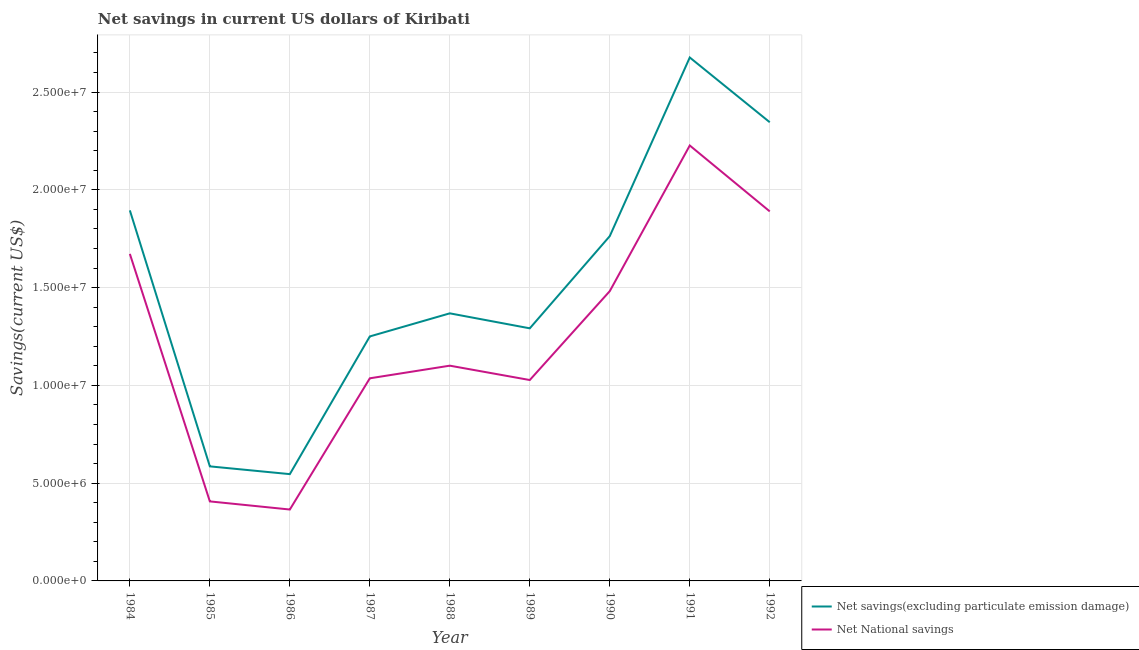How many different coloured lines are there?
Provide a short and direct response. 2. Does the line corresponding to net national savings intersect with the line corresponding to net savings(excluding particulate emission damage)?
Make the answer very short. No. What is the net national savings in 1992?
Offer a very short reply. 1.89e+07. Across all years, what is the maximum net savings(excluding particulate emission damage)?
Ensure brevity in your answer.  2.68e+07. Across all years, what is the minimum net national savings?
Give a very brief answer. 3.65e+06. In which year was the net savings(excluding particulate emission damage) maximum?
Make the answer very short. 1991. In which year was the net savings(excluding particulate emission damage) minimum?
Offer a terse response. 1986. What is the total net national savings in the graph?
Your answer should be compact. 1.12e+08. What is the difference between the net savings(excluding particulate emission damage) in 1986 and that in 1988?
Keep it short and to the point. -8.22e+06. What is the difference between the net savings(excluding particulate emission damage) in 1991 and the net national savings in 1992?
Keep it short and to the point. 7.87e+06. What is the average net national savings per year?
Provide a succinct answer. 1.25e+07. In the year 1987, what is the difference between the net national savings and net savings(excluding particulate emission damage)?
Provide a short and direct response. -2.14e+06. In how many years, is the net national savings greater than 10000000 US$?
Make the answer very short. 7. What is the ratio of the net national savings in 1985 to that in 1986?
Keep it short and to the point. 1.11. Is the net savings(excluding particulate emission damage) in 1987 less than that in 1988?
Keep it short and to the point. Yes. What is the difference between the highest and the second highest net national savings?
Your response must be concise. 3.37e+06. What is the difference between the highest and the lowest net national savings?
Your answer should be compact. 1.86e+07. Is the net national savings strictly less than the net savings(excluding particulate emission damage) over the years?
Make the answer very short. Yes. How many lines are there?
Offer a terse response. 2. What is the difference between two consecutive major ticks on the Y-axis?
Provide a short and direct response. 5.00e+06. Where does the legend appear in the graph?
Give a very brief answer. Bottom right. How are the legend labels stacked?
Provide a short and direct response. Vertical. What is the title of the graph?
Make the answer very short. Net savings in current US dollars of Kiribati. What is the label or title of the Y-axis?
Offer a terse response. Savings(current US$). What is the Savings(current US$) in Net savings(excluding particulate emission damage) in 1984?
Make the answer very short. 1.89e+07. What is the Savings(current US$) in Net National savings in 1984?
Keep it short and to the point. 1.67e+07. What is the Savings(current US$) of Net savings(excluding particulate emission damage) in 1985?
Provide a succinct answer. 5.86e+06. What is the Savings(current US$) of Net National savings in 1985?
Ensure brevity in your answer.  4.07e+06. What is the Savings(current US$) in Net savings(excluding particulate emission damage) in 1986?
Give a very brief answer. 5.46e+06. What is the Savings(current US$) in Net National savings in 1986?
Your answer should be compact. 3.65e+06. What is the Savings(current US$) of Net savings(excluding particulate emission damage) in 1987?
Your answer should be very brief. 1.25e+07. What is the Savings(current US$) of Net National savings in 1987?
Your response must be concise. 1.04e+07. What is the Savings(current US$) of Net savings(excluding particulate emission damage) in 1988?
Make the answer very short. 1.37e+07. What is the Savings(current US$) in Net National savings in 1988?
Give a very brief answer. 1.10e+07. What is the Savings(current US$) of Net savings(excluding particulate emission damage) in 1989?
Give a very brief answer. 1.29e+07. What is the Savings(current US$) in Net National savings in 1989?
Make the answer very short. 1.03e+07. What is the Savings(current US$) of Net savings(excluding particulate emission damage) in 1990?
Keep it short and to the point. 1.76e+07. What is the Savings(current US$) of Net National savings in 1990?
Keep it short and to the point. 1.48e+07. What is the Savings(current US$) in Net savings(excluding particulate emission damage) in 1991?
Make the answer very short. 2.68e+07. What is the Savings(current US$) in Net National savings in 1991?
Provide a succinct answer. 2.23e+07. What is the Savings(current US$) of Net savings(excluding particulate emission damage) in 1992?
Provide a succinct answer. 2.35e+07. What is the Savings(current US$) in Net National savings in 1992?
Your answer should be very brief. 1.89e+07. Across all years, what is the maximum Savings(current US$) in Net savings(excluding particulate emission damage)?
Provide a short and direct response. 2.68e+07. Across all years, what is the maximum Savings(current US$) of Net National savings?
Keep it short and to the point. 2.23e+07. Across all years, what is the minimum Savings(current US$) of Net savings(excluding particulate emission damage)?
Offer a terse response. 5.46e+06. Across all years, what is the minimum Savings(current US$) of Net National savings?
Offer a terse response. 3.65e+06. What is the total Savings(current US$) in Net savings(excluding particulate emission damage) in the graph?
Offer a terse response. 1.37e+08. What is the total Savings(current US$) of Net National savings in the graph?
Provide a succinct answer. 1.12e+08. What is the difference between the Savings(current US$) of Net savings(excluding particulate emission damage) in 1984 and that in 1985?
Your answer should be very brief. 1.31e+07. What is the difference between the Savings(current US$) of Net National savings in 1984 and that in 1985?
Your response must be concise. 1.27e+07. What is the difference between the Savings(current US$) in Net savings(excluding particulate emission damage) in 1984 and that in 1986?
Offer a very short reply. 1.35e+07. What is the difference between the Savings(current US$) of Net National savings in 1984 and that in 1986?
Your answer should be compact. 1.31e+07. What is the difference between the Savings(current US$) in Net savings(excluding particulate emission damage) in 1984 and that in 1987?
Give a very brief answer. 6.45e+06. What is the difference between the Savings(current US$) in Net National savings in 1984 and that in 1987?
Ensure brevity in your answer.  6.36e+06. What is the difference between the Savings(current US$) in Net savings(excluding particulate emission damage) in 1984 and that in 1988?
Your answer should be compact. 5.26e+06. What is the difference between the Savings(current US$) in Net National savings in 1984 and that in 1988?
Give a very brief answer. 5.72e+06. What is the difference between the Savings(current US$) in Net savings(excluding particulate emission damage) in 1984 and that in 1989?
Give a very brief answer. 6.03e+06. What is the difference between the Savings(current US$) in Net National savings in 1984 and that in 1989?
Keep it short and to the point. 6.45e+06. What is the difference between the Savings(current US$) of Net savings(excluding particulate emission damage) in 1984 and that in 1990?
Provide a short and direct response. 1.32e+06. What is the difference between the Savings(current US$) of Net National savings in 1984 and that in 1990?
Make the answer very short. 1.90e+06. What is the difference between the Savings(current US$) in Net savings(excluding particulate emission damage) in 1984 and that in 1991?
Keep it short and to the point. -7.82e+06. What is the difference between the Savings(current US$) in Net National savings in 1984 and that in 1991?
Keep it short and to the point. -5.54e+06. What is the difference between the Savings(current US$) of Net savings(excluding particulate emission damage) in 1984 and that in 1992?
Give a very brief answer. -4.51e+06. What is the difference between the Savings(current US$) in Net National savings in 1984 and that in 1992?
Your response must be concise. -2.17e+06. What is the difference between the Savings(current US$) of Net savings(excluding particulate emission damage) in 1985 and that in 1986?
Give a very brief answer. 3.97e+05. What is the difference between the Savings(current US$) in Net National savings in 1985 and that in 1986?
Your answer should be very brief. 4.16e+05. What is the difference between the Savings(current US$) in Net savings(excluding particulate emission damage) in 1985 and that in 1987?
Offer a very short reply. -6.64e+06. What is the difference between the Savings(current US$) of Net National savings in 1985 and that in 1987?
Offer a terse response. -6.29e+06. What is the difference between the Savings(current US$) of Net savings(excluding particulate emission damage) in 1985 and that in 1988?
Offer a very short reply. -7.82e+06. What is the difference between the Savings(current US$) of Net National savings in 1985 and that in 1988?
Give a very brief answer. -6.94e+06. What is the difference between the Savings(current US$) in Net savings(excluding particulate emission damage) in 1985 and that in 1989?
Your response must be concise. -7.06e+06. What is the difference between the Savings(current US$) of Net National savings in 1985 and that in 1989?
Ensure brevity in your answer.  -6.21e+06. What is the difference between the Savings(current US$) of Net savings(excluding particulate emission damage) in 1985 and that in 1990?
Ensure brevity in your answer.  -1.18e+07. What is the difference between the Savings(current US$) of Net National savings in 1985 and that in 1990?
Offer a terse response. -1.08e+07. What is the difference between the Savings(current US$) of Net savings(excluding particulate emission damage) in 1985 and that in 1991?
Ensure brevity in your answer.  -2.09e+07. What is the difference between the Savings(current US$) in Net National savings in 1985 and that in 1991?
Your answer should be compact. -1.82e+07. What is the difference between the Savings(current US$) in Net savings(excluding particulate emission damage) in 1985 and that in 1992?
Your response must be concise. -1.76e+07. What is the difference between the Savings(current US$) of Net National savings in 1985 and that in 1992?
Keep it short and to the point. -1.48e+07. What is the difference between the Savings(current US$) of Net savings(excluding particulate emission damage) in 1986 and that in 1987?
Provide a succinct answer. -7.04e+06. What is the difference between the Savings(current US$) of Net National savings in 1986 and that in 1987?
Provide a short and direct response. -6.71e+06. What is the difference between the Savings(current US$) of Net savings(excluding particulate emission damage) in 1986 and that in 1988?
Your answer should be very brief. -8.22e+06. What is the difference between the Savings(current US$) in Net National savings in 1986 and that in 1988?
Your answer should be compact. -7.36e+06. What is the difference between the Savings(current US$) in Net savings(excluding particulate emission damage) in 1986 and that in 1989?
Give a very brief answer. -7.46e+06. What is the difference between the Savings(current US$) in Net National savings in 1986 and that in 1989?
Offer a very short reply. -6.62e+06. What is the difference between the Savings(current US$) of Net savings(excluding particulate emission damage) in 1986 and that in 1990?
Your answer should be very brief. -1.22e+07. What is the difference between the Savings(current US$) of Net National savings in 1986 and that in 1990?
Ensure brevity in your answer.  -1.12e+07. What is the difference between the Savings(current US$) of Net savings(excluding particulate emission damage) in 1986 and that in 1991?
Provide a succinct answer. -2.13e+07. What is the difference between the Savings(current US$) of Net National savings in 1986 and that in 1991?
Offer a very short reply. -1.86e+07. What is the difference between the Savings(current US$) of Net savings(excluding particulate emission damage) in 1986 and that in 1992?
Your response must be concise. -1.80e+07. What is the difference between the Savings(current US$) of Net National savings in 1986 and that in 1992?
Make the answer very short. -1.52e+07. What is the difference between the Savings(current US$) in Net savings(excluding particulate emission damage) in 1987 and that in 1988?
Give a very brief answer. -1.18e+06. What is the difference between the Savings(current US$) of Net National savings in 1987 and that in 1988?
Provide a short and direct response. -6.46e+05. What is the difference between the Savings(current US$) in Net savings(excluding particulate emission damage) in 1987 and that in 1989?
Offer a very short reply. -4.14e+05. What is the difference between the Savings(current US$) in Net National savings in 1987 and that in 1989?
Offer a terse response. 8.81e+04. What is the difference between the Savings(current US$) in Net savings(excluding particulate emission damage) in 1987 and that in 1990?
Provide a succinct answer. -5.13e+06. What is the difference between the Savings(current US$) of Net National savings in 1987 and that in 1990?
Your answer should be compact. -4.46e+06. What is the difference between the Savings(current US$) of Net savings(excluding particulate emission damage) in 1987 and that in 1991?
Ensure brevity in your answer.  -1.43e+07. What is the difference between the Savings(current US$) in Net National savings in 1987 and that in 1991?
Your answer should be very brief. -1.19e+07. What is the difference between the Savings(current US$) in Net savings(excluding particulate emission damage) in 1987 and that in 1992?
Your response must be concise. -1.10e+07. What is the difference between the Savings(current US$) of Net National savings in 1987 and that in 1992?
Make the answer very short. -8.53e+06. What is the difference between the Savings(current US$) in Net savings(excluding particulate emission damage) in 1988 and that in 1989?
Provide a succinct answer. 7.66e+05. What is the difference between the Savings(current US$) of Net National savings in 1988 and that in 1989?
Ensure brevity in your answer.  7.34e+05. What is the difference between the Savings(current US$) of Net savings(excluding particulate emission damage) in 1988 and that in 1990?
Your answer should be very brief. -3.95e+06. What is the difference between the Savings(current US$) of Net National savings in 1988 and that in 1990?
Provide a succinct answer. -3.81e+06. What is the difference between the Savings(current US$) in Net savings(excluding particulate emission damage) in 1988 and that in 1991?
Give a very brief answer. -1.31e+07. What is the difference between the Savings(current US$) in Net National savings in 1988 and that in 1991?
Give a very brief answer. -1.13e+07. What is the difference between the Savings(current US$) of Net savings(excluding particulate emission damage) in 1988 and that in 1992?
Your answer should be very brief. -9.77e+06. What is the difference between the Savings(current US$) in Net National savings in 1988 and that in 1992?
Provide a short and direct response. -7.89e+06. What is the difference between the Savings(current US$) of Net savings(excluding particulate emission damage) in 1989 and that in 1990?
Provide a short and direct response. -4.72e+06. What is the difference between the Savings(current US$) in Net National savings in 1989 and that in 1990?
Provide a short and direct response. -4.55e+06. What is the difference between the Savings(current US$) in Net savings(excluding particulate emission damage) in 1989 and that in 1991?
Provide a succinct answer. -1.38e+07. What is the difference between the Savings(current US$) in Net National savings in 1989 and that in 1991?
Give a very brief answer. -1.20e+07. What is the difference between the Savings(current US$) of Net savings(excluding particulate emission damage) in 1989 and that in 1992?
Your answer should be compact. -1.05e+07. What is the difference between the Savings(current US$) of Net National savings in 1989 and that in 1992?
Give a very brief answer. -8.62e+06. What is the difference between the Savings(current US$) in Net savings(excluding particulate emission damage) in 1990 and that in 1991?
Your answer should be very brief. -9.13e+06. What is the difference between the Savings(current US$) of Net National savings in 1990 and that in 1991?
Keep it short and to the point. -7.45e+06. What is the difference between the Savings(current US$) in Net savings(excluding particulate emission damage) in 1990 and that in 1992?
Provide a short and direct response. -5.82e+06. What is the difference between the Savings(current US$) in Net National savings in 1990 and that in 1992?
Your answer should be very brief. -4.08e+06. What is the difference between the Savings(current US$) of Net savings(excluding particulate emission damage) in 1991 and that in 1992?
Your answer should be compact. 3.31e+06. What is the difference between the Savings(current US$) in Net National savings in 1991 and that in 1992?
Ensure brevity in your answer.  3.37e+06. What is the difference between the Savings(current US$) of Net savings(excluding particulate emission damage) in 1984 and the Savings(current US$) of Net National savings in 1985?
Offer a very short reply. 1.49e+07. What is the difference between the Savings(current US$) in Net savings(excluding particulate emission damage) in 1984 and the Savings(current US$) in Net National savings in 1986?
Offer a terse response. 1.53e+07. What is the difference between the Savings(current US$) of Net savings(excluding particulate emission damage) in 1984 and the Savings(current US$) of Net National savings in 1987?
Ensure brevity in your answer.  8.59e+06. What is the difference between the Savings(current US$) of Net savings(excluding particulate emission damage) in 1984 and the Savings(current US$) of Net National savings in 1988?
Provide a succinct answer. 7.94e+06. What is the difference between the Savings(current US$) in Net savings(excluding particulate emission damage) in 1984 and the Savings(current US$) in Net National savings in 1989?
Your answer should be very brief. 8.67e+06. What is the difference between the Savings(current US$) of Net savings(excluding particulate emission damage) in 1984 and the Savings(current US$) of Net National savings in 1990?
Your response must be concise. 4.13e+06. What is the difference between the Savings(current US$) in Net savings(excluding particulate emission damage) in 1984 and the Savings(current US$) in Net National savings in 1991?
Your response must be concise. -3.32e+06. What is the difference between the Savings(current US$) of Net savings(excluding particulate emission damage) in 1984 and the Savings(current US$) of Net National savings in 1992?
Give a very brief answer. 5.24e+04. What is the difference between the Savings(current US$) of Net savings(excluding particulate emission damage) in 1985 and the Savings(current US$) of Net National savings in 1986?
Provide a short and direct response. 2.21e+06. What is the difference between the Savings(current US$) in Net savings(excluding particulate emission damage) in 1985 and the Savings(current US$) in Net National savings in 1987?
Provide a succinct answer. -4.50e+06. What is the difference between the Savings(current US$) of Net savings(excluding particulate emission damage) in 1985 and the Savings(current US$) of Net National savings in 1988?
Ensure brevity in your answer.  -5.15e+06. What is the difference between the Savings(current US$) of Net savings(excluding particulate emission damage) in 1985 and the Savings(current US$) of Net National savings in 1989?
Provide a short and direct response. -4.41e+06. What is the difference between the Savings(current US$) in Net savings(excluding particulate emission damage) in 1985 and the Savings(current US$) in Net National savings in 1990?
Your answer should be very brief. -8.96e+06. What is the difference between the Savings(current US$) of Net savings(excluding particulate emission damage) in 1985 and the Savings(current US$) of Net National savings in 1991?
Provide a short and direct response. -1.64e+07. What is the difference between the Savings(current US$) of Net savings(excluding particulate emission damage) in 1985 and the Savings(current US$) of Net National savings in 1992?
Your answer should be very brief. -1.30e+07. What is the difference between the Savings(current US$) of Net savings(excluding particulate emission damage) in 1986 and the Savings(current US$) of Net National savings in 1987?
Your answer should be very brief. -4.90e+06. What is the difference between the Savings(current US$) in Net savings(excluding particulate emission damage) in 1986 and the Savings(current US$) in Net National savings in 1988?
Offer a terse response. -5.55e+06. What is the difference between the Savings(current US$) in Net savings(excluding particulate emission damage) in 1986 and the Savings(current US$) in Net National savings in 1989?
Your answer should be compact. -4.81e+06. What is the difference between the Savings(current US$) in Net savings(excluding particulate emission damage) in 1986 and the Savings(current US$) in Net National savings in 1990?
Offer a terse response. -9.36e+06. What is the difference between the Savings(current US$) in Net savings(excluding particulate emission damage) in 1986 and the Savings(current US$) in Net National savings in 1991?
Your answer should be very brief. -1.68e+07. What is the difference between the Savings(current US$) of Net savings(excluding particulate emission damage) in 1986 and the Savings(current US$) of Net National savings in 1992?
Your response must be concise. -1.34e+07. What is the difference between the Savings(current US$) in Net savings(excluding particulate emission damage) in 1987 and the Savings(current US$) in Net National savings in 1988?
Keep it short and to the point. 1.50e+06. What is the difference between the Savings(current US$) of Net savings(excluding particulate emission damage) in 1987 and the Savings(current US$) of Net National savings in 1989?
Provide a succinct answer. 2.23e+06. What is the difference between the Savings(current US$) in Net savings(excluding particulate emission damage) in 1987 and the Savings(current US$) in Net National savings in 1990?
Offer a terse response. -2.32e+06. What is the difference between the Savings(current US$) in Net savings(excluding particulate emission damage) in 1987 and the Savings(current US$) in Net National savings in 1991?
Your response must be concise. -9.76e+06. What is the difference between the Savings(current US$) of Net savings(excluding particulate emission damage) in 1987 and the Savings(current US$) of Net National savings in 1992?
Your answer should be very brief. -6.39e+06. What is the difference between the Savings(current US$) of Net savings(excluding particulate emission damage) in 1988 and the Savings(current US$) of Net National savings in 1989?
Ensure brevity in your answer.  3.41e+06. What is the difference between the Savings(current US$) in Net savings(excluding particulate emission damage) in 1988 and the Savings(current US$) in Net National savings in 1990?
Give a very brief answer. -1.14e+06. What is the difference between the Savings(current US$) in Net savings(excluding particulate emission damage) in 1988 and the Savings(current US$) in Net National savings in 1991?
Your answer should be very brief. -8.58e+06. What is the difference between the Savings(current US$) of Net savings(excluding particulate emission damage) in 1988 and the Savings(current US$) of Net National savings in 1992?
Your answer should be compact. -5.21e+06. What is the difference between the Savings(current US$) of Net savings(excluding particulate emission damage) in 1989 and the Savings(current US$) of Net National savings in 1990?
Ensure brevity in your answer.  -1.90e+06. What is the difference between the Savings(current US$) of Net savings(excluding particulate emission damage) in 1989 and the Savings(current US$) of Net National savings in 1991?
Offer a very short reply. -9.35e+06. What is the difference between the Savings(current US$) of Net savings(excluding particulate emission damage) in 1989 and the Savings(current US$) of Net National savings in 1992?
Provide a short and direct response. -5.98e+06. What is the difference between the Savings(current US$) of Net savings(excluding particulate emission damage) in 1990 and the Savings(current US$) of Net National savings in 1991?
Your response must be concise. -4.63e+06. What is the difference between the Savings(current US$) in Net savings(excluding particulate emission damage) in 1990 and the Savings(current US$) in Net National savings in 1992?
Your response must be concise. -1.26e+06. What is the difference between the Savings(current US$) of Net savings(excluding particulate emission damage) in 1991 and the Savings(current US$) of Net National savings in 1992?
Offer a very short reply. 7.87e+06. What is the average Savings(current US$) in Net savings(excluding particulate emission damage) per year?
Make the answer very short. 1.52e+07. What is the average Savings(current US$) of Net National savings per year?
Provide a succinct answer. 1.25e+07. In the year 1984, what is the difference between the Savings(current US$) in Net savings(excluding particulate emission damage) and Savings(current US$) in Net National savings?
Keep it short and to the point. 2.23e+06. In the year 1985, what is the difference between the Savings(current US$) of Net savings(excluding particulate emission damage) and Savings(current US$) of Net National savings?
Provide a succinct answer. 1.79e+06. In the year 1986, what is the difference between the Savings(current US$) in Net savings(excluding particulate emission damage) and Savings(current US$) in Net National savings?
Provide a succinct answer. 1.81e+06. In the year 1987, what is the difference between the Savings(current US$) of Net savings(excluding particulate emission damage) and Savings(current US$) of Net National savings?
Make the answer very short. 2.14e+06. In the year 1988, what is the difference between the Savings(current US$) of Net savings(excluding particulate emission damage) and Savings(current US$) of Net National savings?
Offer a terse response. 2.68e+06. In the year 1989, what is the difference between the Savings(current US$) in Net savings(excluding particulate emission damage) and Savings(current US$) in Net National savings?
Make the answer very short. 2.64e+06. In the year 1990, what is the difference between the Savings(current US$) in Net savings(excluding particulate emission damage) and Savings(current US$) in Net National savings?
Keep it short and to the point. 2.81e+06. In the year 1991, what is the difference between the Savings(current US$) of Net savings(excluding particulate emission damage) and Savings(current US$) of Net National savings?
Your answer should be compact. 4.50e+06. In the year 1992, what is the difference between the Savings(current US$) in Net savings(excluding particulate emission damage) and Savings(current US$) in Net National savings?
Keep it short and to the point. 4.56e+06. What is the ratio of the Savings(current US$) of Net savings(excluding particulate emission damage) in 1984 to that in 1985?
Ensure brevity in your answer.  3.23. What is the ratio of the Savings(current US$) in Net National savings in 1984 to that in 1985?
Your answer should be compact. 4.11. What is the ratio of the Savings(current US$) of Net savings(excluding particulate emission damage) in 1984 to that in 1986?
Ensure brevity in your answer.  3.47. What is the ratio of the Savings(current US$) of Net National savings in 1984 to that in 1986?
Ensure brevity in your answer.  4.58. What is the ratio of the Savings(current US$) in Net savings(excluding particulate emission damage) in 1984 to that in 1987?
Ensure brevity in your answer.  1.52. What is the ratio of the Savings(current US$) in Net National savings in 1984 to that in 1987?
Offer a terse response. 1.61. What is the ratio of the Savings(current US$) in Net savings(excluding particulate emission damage) in 1984 to that in 1988?
Give a very brief answer. 1.38. What is the ratio of the Savings(current US$) of Net National savings in 1984 to that in 1988?
Provide a succinct answer. 1.52. What is the ratio of the Savings(current US$) in Net savings(excluding particulate emission damage) in 1984 to that in 1989?
Offer a terse response. 1.47. What is the ratio of the Savings(current US$) of Net National savings in 1984 to that in 1989?
Offer a very short reply. 1.63. What is the ratio of the Savings(current US$) in Net savings(excluding particulate emission damage) in 1984 to that in 1990?
Give a very brief answer. 1.07. What is the ratio of the Savings(current US$) in Net National savings in 1984 to that in 1990?
Make the answer very short. 1.13. What is the ratio of the Savings(current US$) in Net savings(excluding particulate emission damage) in 1984 to that in 1991?
Ensure brevity in your answer.  0.71. What is the ratio of the Savings(current US$) in Net National savings in 1984 to that in 1991?
Ensure brevity in your answer.  0.75. What is the ratio of the Savings(current US$) in Net savings(excluding particulate emission damage) in 1984 to that in 1992?
Offer a very short reply. 0.81. What is the ratio of the Savings(current US$) of Net National savings in 1984 to that in 1992?
Your answer should be compact. 0.89. What is the ratio of the Savings(current US$) in Net savings(excluding particulate emission damage) in 1985 to that in 1986?
Provide a short and direct response. 1.07. What is the ratio of the Savings(current US$) of Net National savings in 1985 to that in 1986?
Provide a succinct answer. 1.11. What is the ratio of the Savings(current US$) of Net savings(excluding particulate emission damage) in 1985 to that in 1987?
Keep it short and to the point. 0.47. What is the ratio of the Savings(current US$) of Net National savings in 1985 to that in 1987?
Make the answer very short. 0.39. What is the ratio of the Savings(current US$) in Net savings(excluding particulate emission damage) in 1985 to that in 1988?
Your answer should be compact. 0.43. What is the ratio of the Savings(current US$) of Net National savings in 1985 to that in 1988?
Keep it short and to the point. 0.37. What is the ratio of the Savings(current US$) in Net savings(excluding particulate emission damage) in 1985 to that in 1989?
Provide a short and direct response. 0.45. What is the ratio of the Savings(current US$) in Net National savings in 1985 to that in 1989?
Offer a terse response. 0.4. What is the ratio of the Savings(current US$) in Net savings(excluding particulate emission damage) in 1985 to that in 1990?
Your response must be concise. 0.33. What is the ratio of the Savings(current US$) in Net National savings in 1985 to that in 1990?
Keep it short and to the point. 0.27. What is the ratio of the Savings(current US$) of Net savings(excluding particulate emission damage) in 1985 to that in 1991?
Keep it short and to the point. 0.22. What is the ratio of the Savings(current US$) of Net National savings in 1985 to that in 1991?
Your answer should be compact. 0.18. What is the ratio of the Savings(current US$) in Net savings(excluding particulate emission damage) in 1985 to that in 1992?
Your answer should be compact. 0.25. What is the ratio of the Savings(current US$) in Net National savings in 1985 to that in 1992?
Your response must be concise. 0.22. What is the ratio of the Savings(current US$) in Net savings(excluding particulate emission damage) in 1986 to that in 1987?
Make the answer very short. 0.44. What is the ratio of the Savings(current US$) in Net National savings in 1986 to that in 1987?
Your answer should be very brief. 0.35. What is the ratio of the Savings(current US$) of Net savings(excluding particulate emission damage) in 1986 to that in 1988?
Provide a short and direct response. 0.4. What is the ratio of the Savings(current US$) of Net National savings in 1986 to that in 1988?
Provide a succinct answer. 0.33. What is the ratio of the Savings(current US$) in Net savings(excluding particulate emission damage) in 1986 to that in 1989?
Provide a succinct answer. 0.42. What is the ratio of the Savings(current US$) in Net National savings in 1986 to that in 1989?
Offer a very short reply. 0.36. What is the ratio of the Savings(current US$) in Net savings(excluding particulate emission damage) in 1986 to that in 1990?
Make the answer very short. 0.31. What is the ratio of the Savings(current US$) in Net National savings in 1986 to that in 1990?
Ensure brevity in your answer.  0.25. What is the ratio of the Savings(current US$) in Net savings(excluding particulate emission damage) in 1986 to that in 1991?
Your answer should be very brief. 0.2. What is the ratio of the Savings(current US$) of Net National savings in 1986 to that in 1991?
Make the answer very short. 0.16. What is the ratio of the Savings(current US$) of Net savings(excluding particulate emission damage) in 1986 to that in 1992?
Offer a very short reply. 0.23. What is the ratio of the Savings(current US$) in Net National savings in 1986 to that in 1992?
Keep it short and to the point. 0.19. What is the ratio of the Savings(current US$) of Net savings(excluding particulate emission damage) in 1987 to that in 1988?
Your response must be concise. 0.91. What is the ratio of the Savings(current US$) of Net National savings in 1987 to that in 1988?
Provide a short and direct response. 0.94. What is the ratio of the Savings(current US$) in Net savings(excluding particulate emission damage) in 1987 to that in 1989?
Keep it short and to the point. 0.97. What is the ratio of the Savings(current US$) of Net National savings in 1987 to that in 1989?
Your response must be concise. 1.01. What is the ratio of the Savings(current US$) of Net savings(excluding particulate emission damage) in 1987 to that in 1990?
Provide a short and direct response. 0.71. What is the ratio of the Savings(current US$) of Net National savings in 1987 to that in 1990?
Give a very brief answer. 0.7. What is the ratio of the Savings(current US$) of Net savings(excluding particulate emission damage) in 1987 to that in 1991?
Your response must be concise. 0.47. What is the ratio of the Savings(current US$) in Net National savings in 1987 to that in 1991?
Keep it short and to the point. 0.47. What is the ratio of the Savings(current US$) of Net savings(excluding particulate emission damage) in 1987 to that in 1992?
Your response must be concise. 0.53. What is the ratio of the Savings(current US$) of Net National savings in 1987 to that in 1992?
Offer a terse response. 0.55. What is the ratio of the Savings(current US$) of Net savings(excluding particulate emission damage) in 1988 to that in 1989?
Your answer should be compact. 1.06. What is the ratio of the Savings(current US$) in Net National savings in 1988 to that in 1989?
Your answer should be very brief. 1.07. What is the ratio of the Savings(current US$) of Net savings(excluding particulate emission damage) in 1988 to that in 1990?
Provide a succinct answer. 0.78. What is the ratio of the Savings(current US$) in Net National savings in 1988 to that in 1990?
Provide a succinct answer. 0.74. What is the ratio of the Savings(current US$) of Net savings(excluding particulate emission damage) in 1988 to that in 1991?
Provide a short and direct response. 0.51. What is the ratio of the Savings(current US$) of Net National savings in 1988 to that in 1991?
Your answer should be compact. 0.49. What is the ratio of the Savings(current US$) of Net savings(excluding particulate emission damage) in 1988 to that in 1992?
Provide a short and direct response. 0.58. What is the ratio of the Savings(current US$) of Net National savings in 1988 to that in 1992?
Your answer should be compact. 0.58. What is the ratio of the Savings(current US$) in Net savings(excluding particulate emission damage) in 1989 to that in 1990?
Offer a terse response. 0.73. What is the ratio of the Savings(current US$) of Net National savings in 1989 to that in 1990?
Your answer should be very brief. 0.69. What is the ratio of the Savings(current US$) of Net savings(excluding particulate emission damage) in 1989 to that in 1991?
Your answer should be very brief. 0.48. What is the ratio of the Savings(current US$) of Net National savings in 1989 to that in 1991?
Keep it short and to the point. 0.46. What is the ratio of the Savings(current US$) in Net savings(excluding particulate emission damage) in 1989 to that in 1992?
Give a very brief answer. 0.55. What is the ratio of the Savings(current US$) in Net National savings in 1989 to that in 1992?
Provide a succinct answer. 0.54. What is the ratio of the Savings(current US$) in Net savings(excluding particulate emission damage) in 1990 to that in 1991?
Provide a succinct answer. 0.66. What is the ratio of the Savings(current US$) in Net National savings in 1990 to that in 1991?
Provide a succinct answer. 0.67. What is the ratio of the Savings(current US$) in Net savings(excluding particulate emission damage) in 1990 to that in 1992?
Provide a short and direct response. 0.75. What is the ratio of the Savings(current US$) in Net National savings in 1990 to that in 1992?
Your answer should be very brief. 0.78. What is the ratio of the Savings(current US$) of Net savings(excluding particulate emission damage) in 1991 to that in 1992?
Provide a succinct answer. 1.14. What is the ratio of the Savings(current US$) in Net National savings in 1991 to that in 1992?
Ensure brevity in your answer.  1.18. What is the difference between the highest and the second highest Savings(current US$) in Net savings(excluding particulate emission damage)?
Provide a succinct answer. 3.31e+06. What is the difference between the highest and the second highest Savings(current US$) in Net National savings?
Offer a terse response. 3.37e+06. What is the difference between the highest and the lowest Savings(current US$) of Net savings(excluding particulate emission damage)?
Your response must be concise. 2.13e+07. What is the difference between the highest and the lowest Savings(current US$) of Net National savings?
Your answer should be compact. 1.86e+07. 